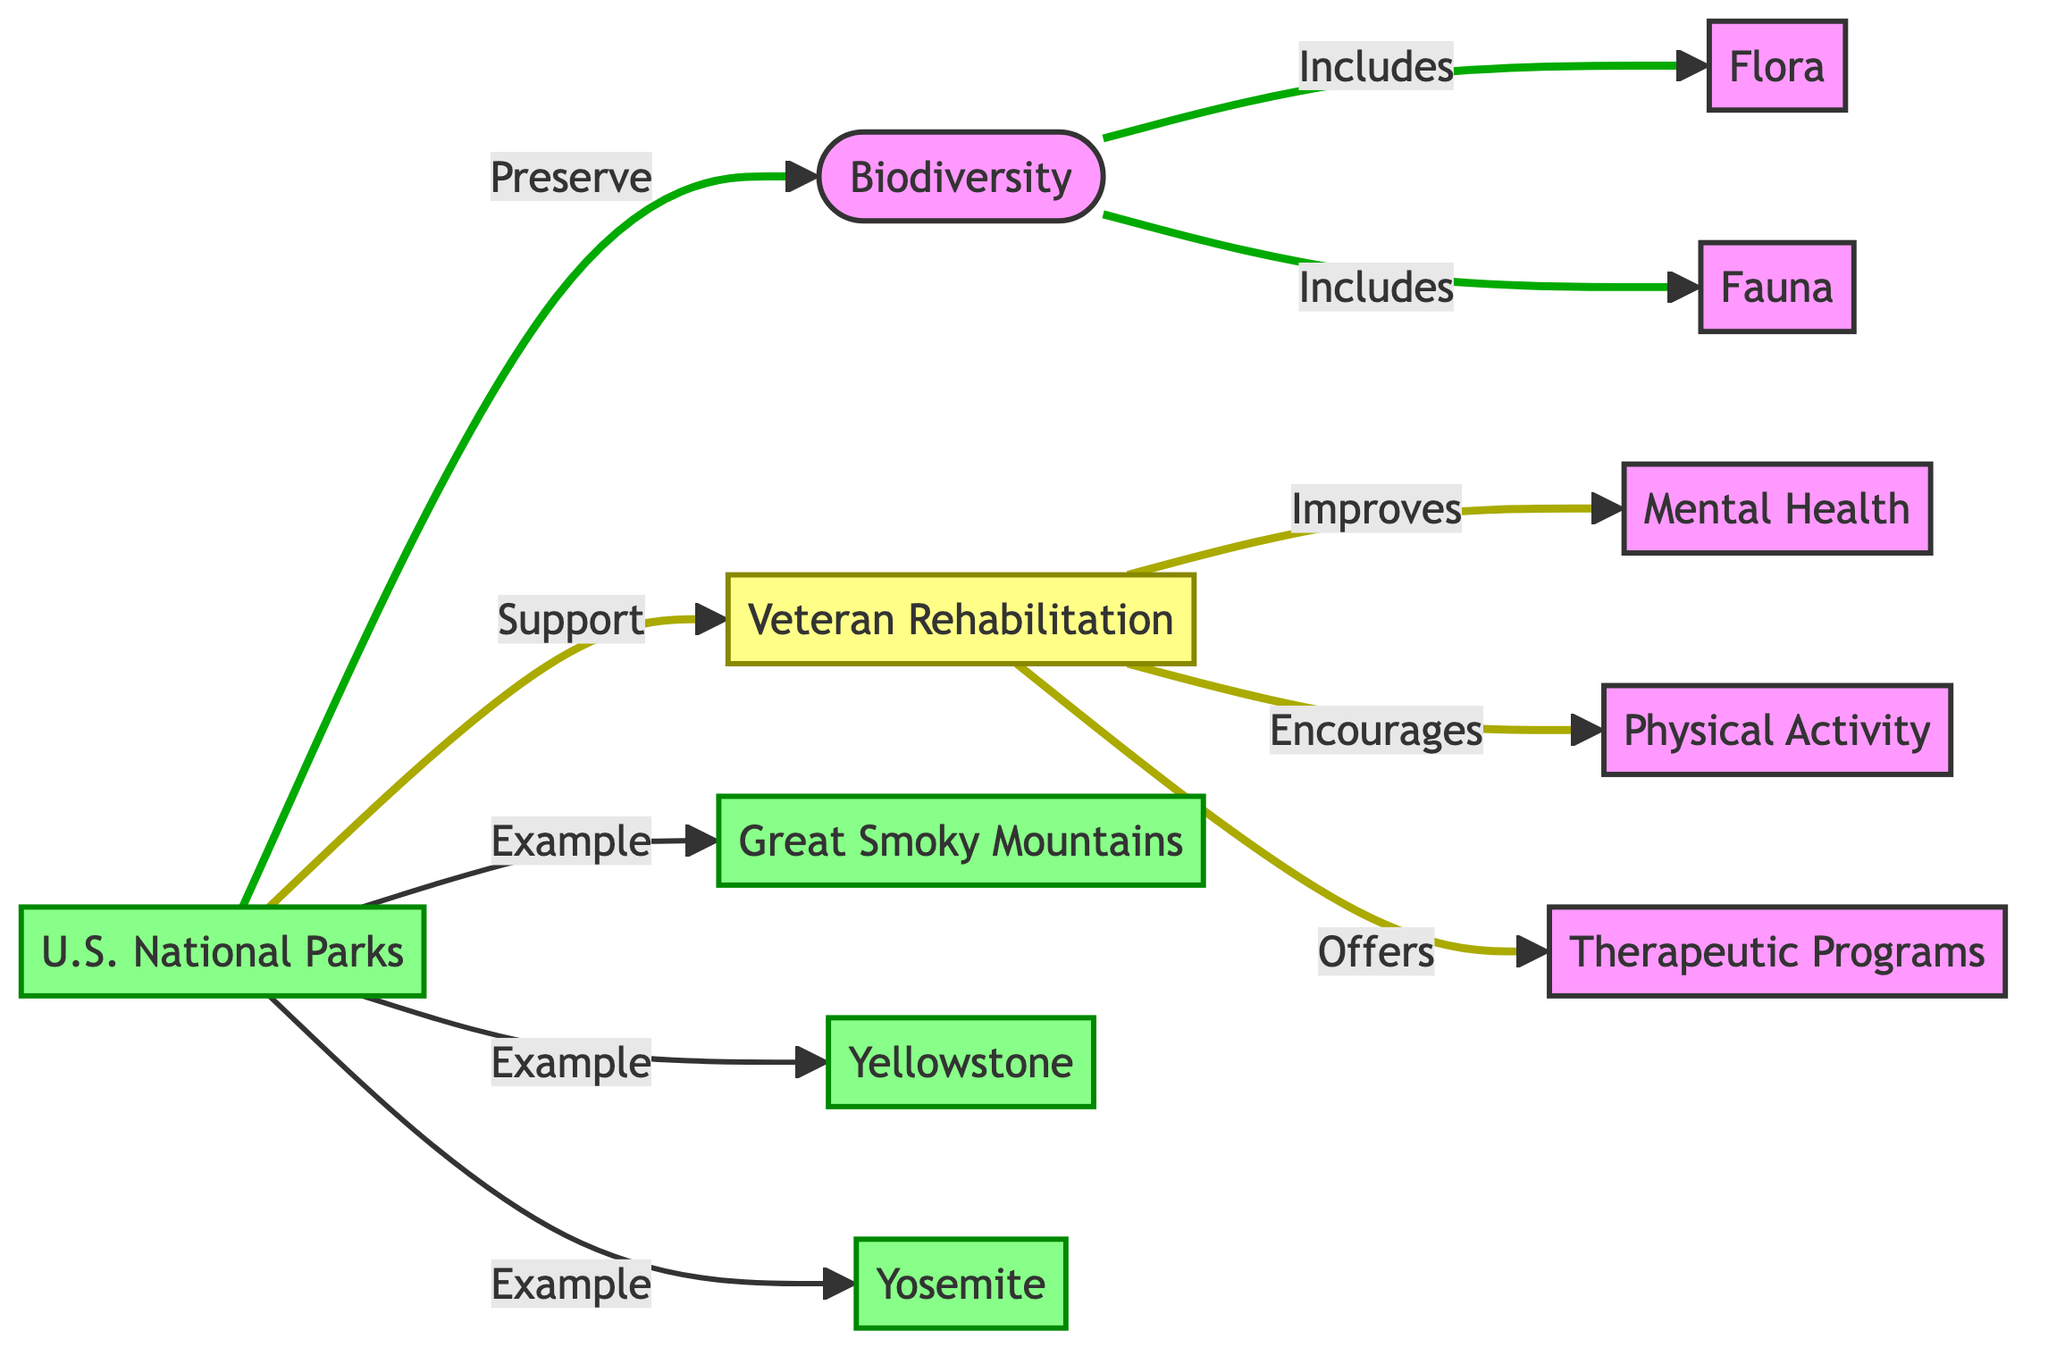What is the main focus of the diagram? The diagram focuses on the relationship between biodiversity in U.S. National Parks and how it supports Veteran Rehabilitation programs. This can be understood from the central nodes and their connections, specifically the links showing how National Parks preserve biodiversity and support veteran rehabilitation.
Answer: Biodiversity and Veteran Rehabilitation How many U.S. National Parks are explicitly mentioned? The diagram lists three U.S. National Parks: Great Smoky Mountains, Yellowstone, and Yosemite. These parks are categorized under the National Parks node, indicating examples of this category.
Answer: Three What are the two main components of biodiversity shown in the diagram? The diagram indicates that biodiversity consists of two main components: Flora and Fauna. These components are specifically connected to the Biodiversity node, showing what biodiversity includes.
Answer: Flora and Fauna How does Veteran Rehabilitation improve mental health according to the diagram? The flow indicates that Veteran Rehabilitation improves mental health as a result of the connection from Veteran Rehabilitation to Mental Health. This relationship is drawn explicitly in the diagram, showing the impact of rehabilitation on mental well-being.
Answer: Improves What role do National Parks play in Veteran Rehabilitation programs? National Parks are shown to support Veteran Rehabilitation in the diagram. This connection indicates that these parks provide a beneficial environment for rehabilitation, directly influencing the health outcomes for veterans.
Answer: Support What type of programs does Veteran Rehabilitation offer? Veteran Rehabilitation offers Therapeutic Programs, as indicated by the direct connection from the Veteran Rehabilitation node to the Therapeutic Programs node in the diagram. This shows the types of support available to veterans.
Answer: Therapeutic Programs What is the relationship between Physical Activity and Veteran Rehabilitation? The diagram shows that Veteran Rehabilitation encourages Physical Activity, which implies that engaging in activities within parks can lead to improved outcomes for veterans. This is linked directly in the flow of the diagram.
Answer: Encourages Which National Park is categorized as an example within the diagram? The diagram specifies Great Smoky Mountains, Yellowstone, and Yosemite as examples of U.S. National Parks, linking them directly under the National Parks node to demonstrate their role.
Answer: Great Smoky Mountains, Yellowstone, Yosemite What type of diagram is used to illustrate the relationships in this data? The diagram is a flowchart, which is used to depict the flow of relationships between different components, such as the connections between biodiversity, national parks, and veteran rehabilitation.
Answer: Flowchart 